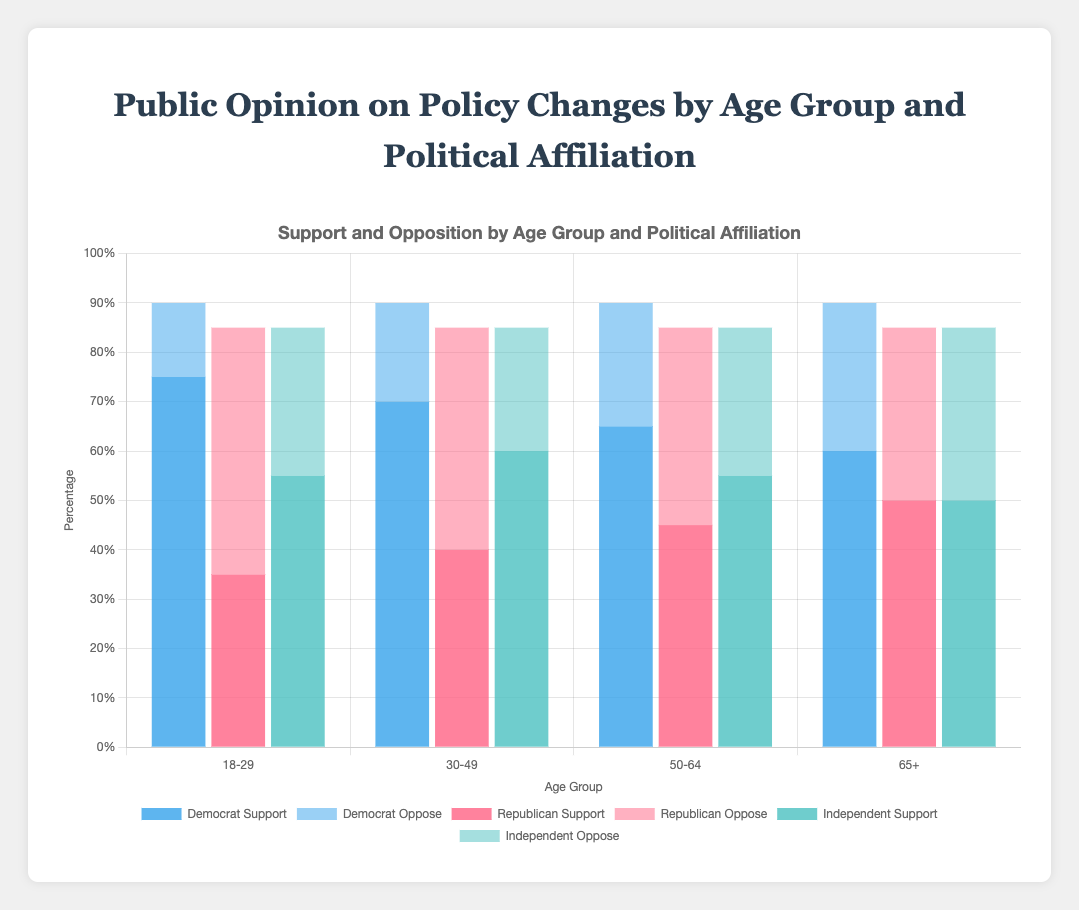Which age group among Democrats has the highest support for policy changes? By examining the height of the blue bars labeled “Democrat Support,” we can see that the 18-29 age group has the tallest bar, indicating the highest support.
Answer: 18-29 Which political affiliation shows the highest opposition in the 50-64 age group? We need to compare the bars for opposition in the 50-64 age group. The light red bar, labeled “Republican Oppose,” is the tallest, indicating the highest opposition among Republicans.
Answer: Republican What is the total percentage of Democrats who either support or oppose policy changes in the 30-49 age group? We sum the Democrat support (0.70) and oppose (0.20) percentages for the 30-49 age group. So, 0.70 + 0.20 = 0.90 or 90%.
Answer: 90% How does support among Independents in the 18-29 age group compare to support among Independents in the 65+ age group? We compare the heights of the green bars labeled “Independent Support” between these two age groups. The 18-29 age group has a bar at 0.55, while the 65+ age group has a bar at 0.50. So, support is greater in the 18-29 age group.
Answer: Greater in 18-29 What is the average support for policy changes among Democrats across all age groups? We sum the support percentages for Democrats across all age groups and then calculate the average: (0.75 + 0.70 + 0.65 + 0.60) / 4 = 2.70 / 4 = 0.675 or 67.5%.
Answer: 67.5% Which age group has the closest levels of support and opposition among Republicans? We compare the heights of the red bars (support) and light red bars (oppose) across all age groups for Republicans. The 65+ age group has the bars closest in height, with support at 50% and opposition at 35%.
Answer: 65+ What percentage of Independents in the 30-49 age group are either neutral or oppose policy changes? We sum the neutral (0.15) and oppose (0.25) percentages for Independents in the 30-49 age group. So, 0.15 + 0.25 = 0.40 or 40%.
Answer: 40% 